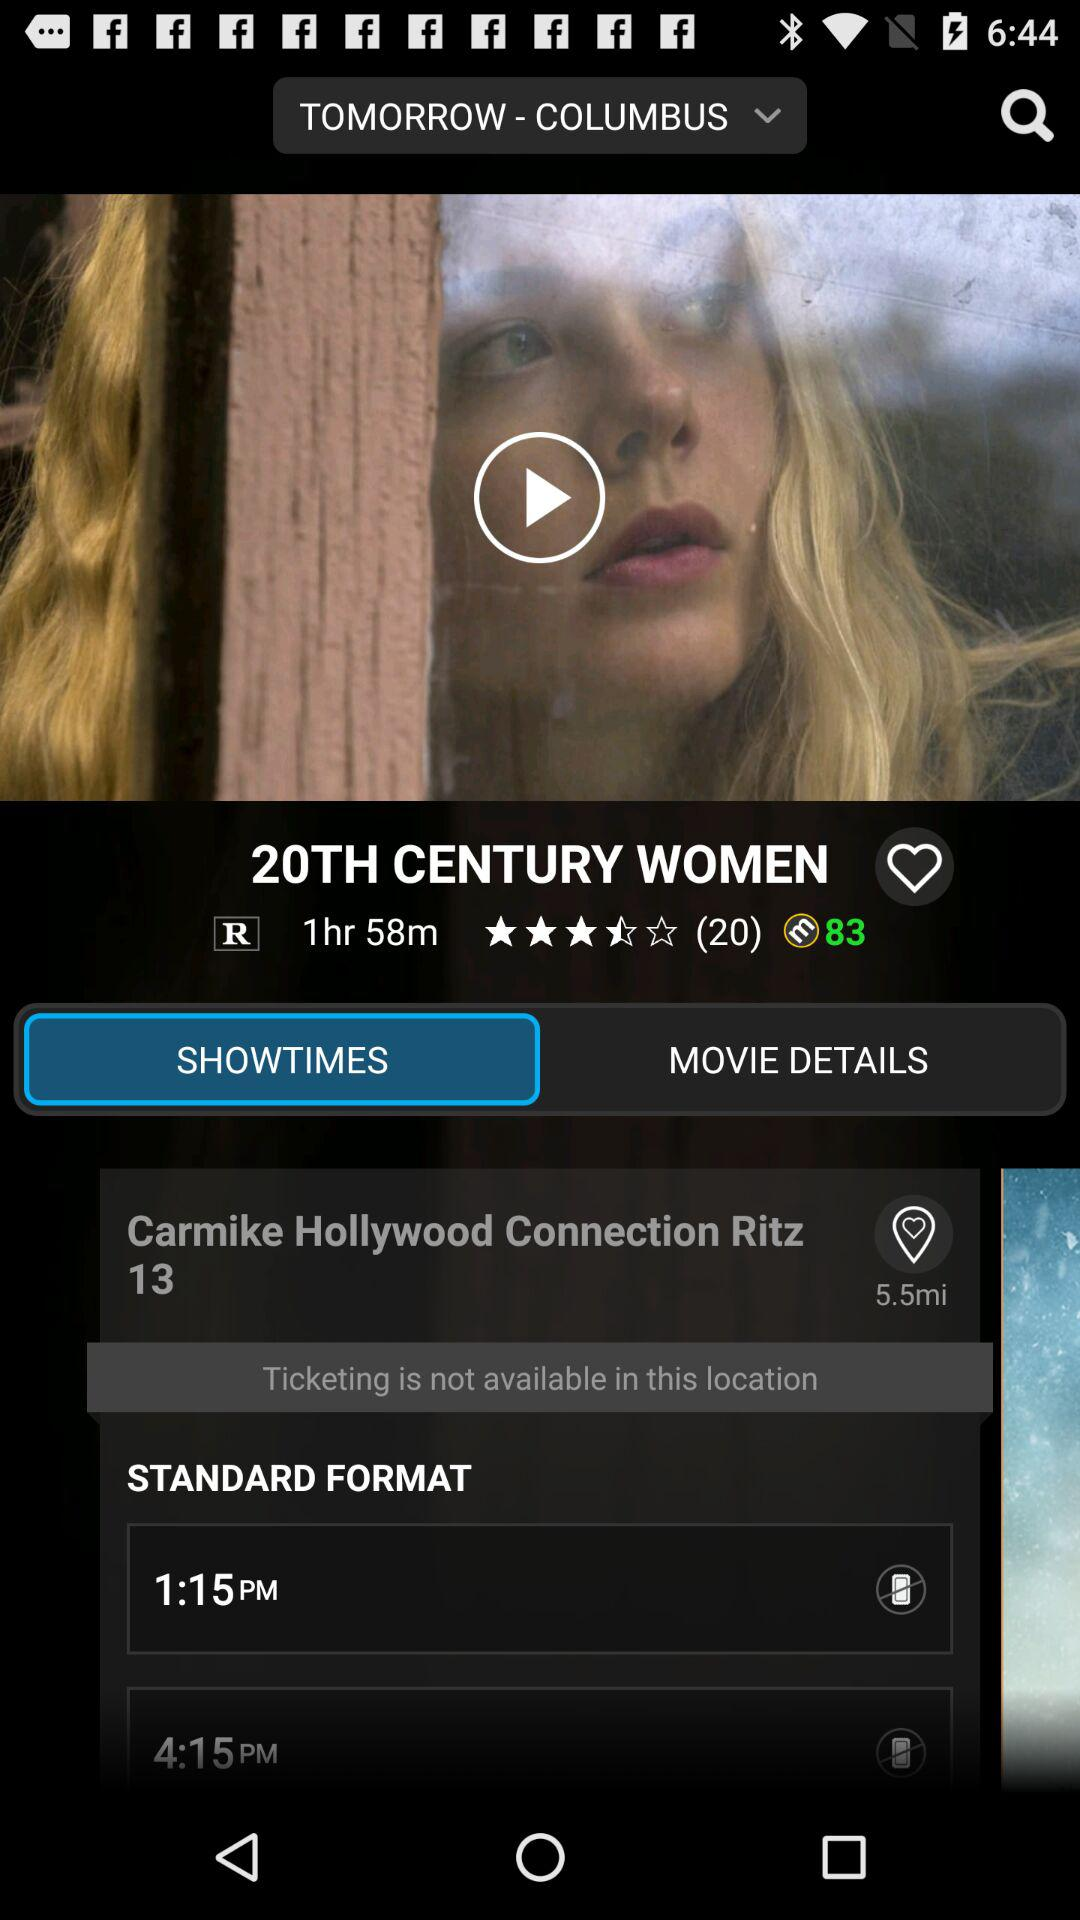How many reviews did the "20TH CENTURY WOMEN" movie get? The movie got 20 reviews. 